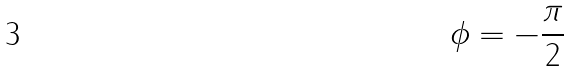<formula> <loc_0><loc_0><loc_500><loc_500>\phi = - \frac { \pi } { 2 }</formula> 